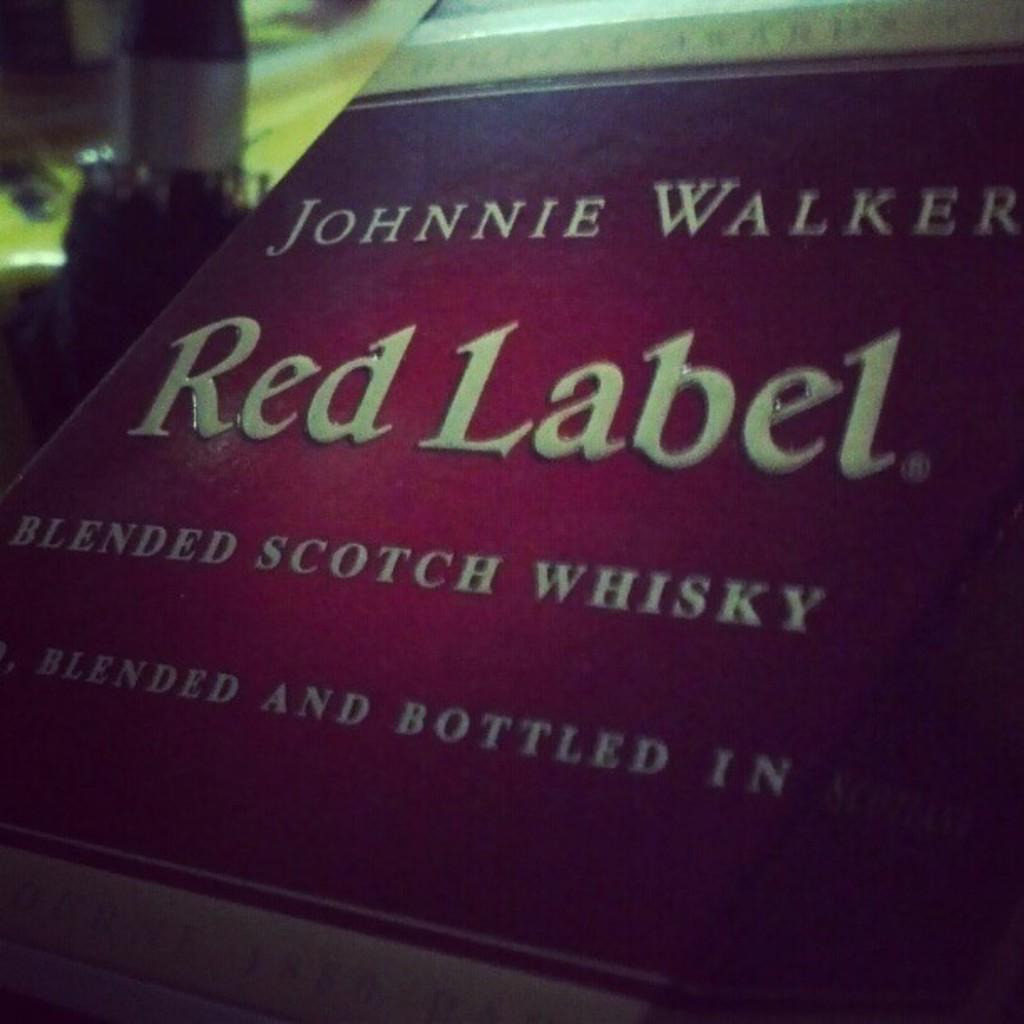What brand of whisky is in this bottle?
Give a very brief answer. Johnnie walker. What kind of alcohol is this?
Give a very brief answer. Whisky. 